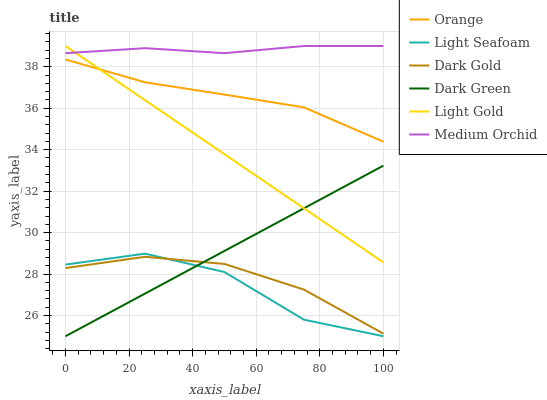Does Light Seafoam have the minimum area under the curve?
Answer yes or no. Yes. Does Medium Orchid have the maximum area under the curve?
Answer yes or no. Yes. Does Orange have the minimum area under the curve?
Answer yes or no. No. Does Orange have the maximum area under the curve?
Answer yes or no. No. Is Light Gold the smoothest?
Answer yes or no. Yes. Is Light Seafoam the roughest?
Answer yes or no. Yes. Is Medium Orchid the smoothest?
Answer yes or no. No. Is Medium Orchid the roughest?
Answer yes or no. No. Does Orange have the lowest value?
Answer yes or no. No. Does Orange have the highest value?
Answer yes or no. No. Is Dark Gold less than Orange?
Answer yes or no. Yes. Is Light Gold greater than Light Seafoam?
Answer yes or no. Yes. Does Dark Gold intersect Orange?
Answer yes or no. No. 